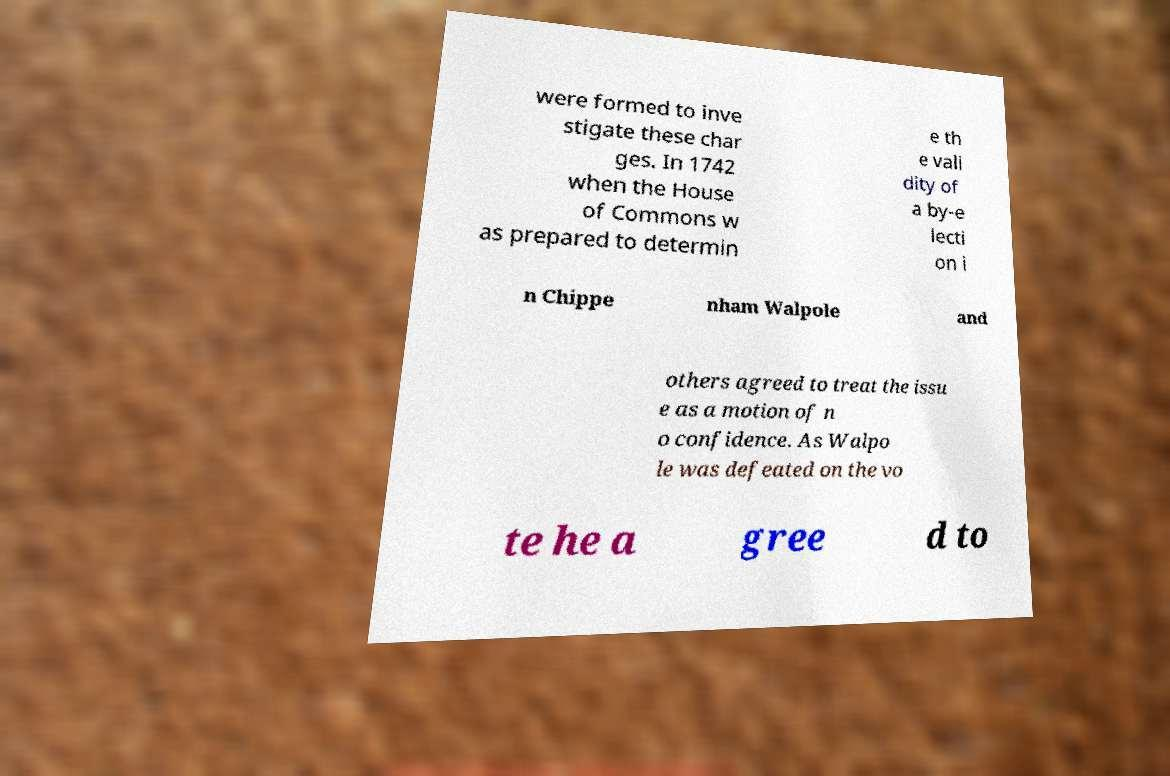There's text embedded in this image that I need extracted. Can you transcribe it verbatim? were formed to inve stigate these char ges. In 1742 when the House of Commons w as prepared to determin e th e vali dity of a by-e lecti on i n Chippe nham Walpole and others agreed to treat the issu e as a motion of n o confidence. As Walpo le was defeated on the vo te he a gree d to 